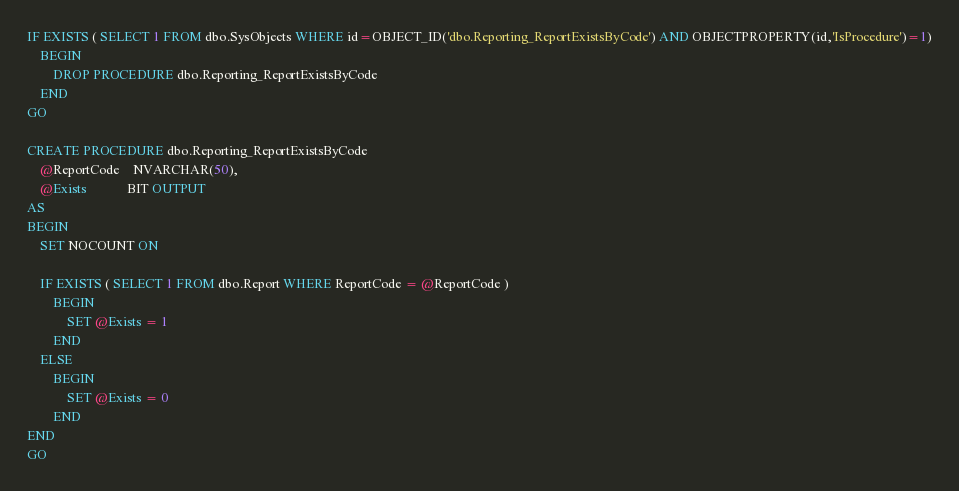Convert code to text. <code><loc_0><loc_0><loc_500><loc_500><_SQL_>IF EXISTS ( SELECT 1 FROM dbo.SysObjects WHERE id=OBJECT_ID('dbo.Reporting_ReportExistsByCode') AND OBJECTPROPERTY(id,'IsProcedure')=1)
	BEGIN
		DROP PROCEDURE dbo.Reporting_ReportExistsByCode
	END
GO

CREATE PROCEDURE dbo.Reporting_ReportExistsByCode
	@ReportCode	NVARCHAR(50),
	@Exists			BIT OUTPUT
AS
BEGIN
	SET NOCOUNT ON 

	IF EXISTS ( SELECT 1 FROM dbo.Report WHERE ReportCode = @ReportCode )
		BEGIN
			SET @Exists = 1
		END
	ELSE
		BEGIN
			SET @Exists = 0
		END		
END
GO   </code> 